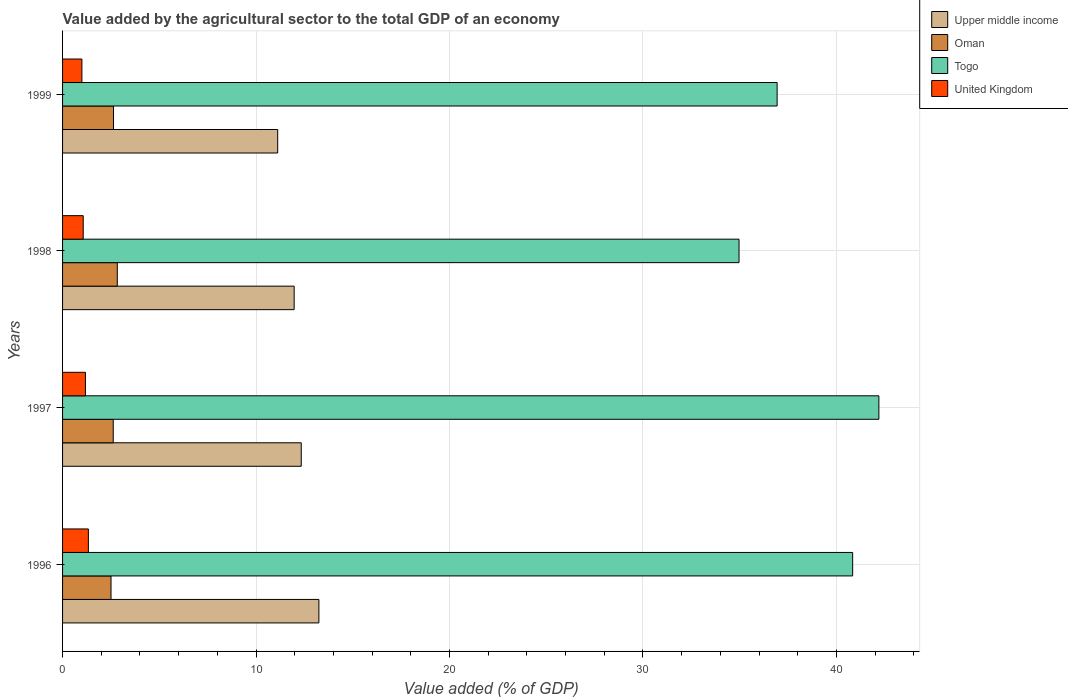How many different coloured bars are there?
Offer a very short reply. 4. Are the number of bars on each tick of the Y-axis equal?
Your answer should be very brief. Yes. How many bars are there on the 3rd tick from the bottom?
Make the answer very short. 4. What is the value added by the agricultural sector to the total GDP in Togo in 1999?
Keep it short and to the point. 36.93. Across all years, what is the maximum value added by the agricultural sector to the total GDP in Upper middle income?
Your response must be concise. 13.25. Across all years, what is the minimum value added by the agricultural sector to the total GDP in Togo?
Give a very brief answer. 34.96. In which year was the value added by the agricultural sector to the total GDP in United Kingdom maximum?
Make the answer very short. 1996. In which year was the value added by the agricultural sector to the total GDP in Oman minimum?
Ensure brevity in your answer.  1996. What is the total value added by the agricultural sector to the total GDP in Togo in the graph?
Ensure brevity in your answer.  154.93. What is the difference between the value added by the agricultural sector to the total GDP in Togo in 1997 and that in 1999?
Make the answer very short. 5.26. What is the difference between the value added by the agricultural sector to the total GDP in United Kingdom in 1998 and the value added by the agricultural sector to the total GDP in Togo in 1997?
Your answer should be compact. -41.13. What is the average value added by the agricultural sector to the total GDP in Oman per year?
Your response must be concise. 2.65. In the year 1996, what is the difference between the value added by the agricultural sector to the total GDP in United Kingdom and value added by the agricultural sector to the total GDP in Oman?
Your response must be concise. -1.17. In how many years, is the value added by the agricultural sector to the total GDP in Oman greater than 32 %?
Make the answer very short. 0. What is the ratio of the value added by the agricultural sector to the total GDP in United Kingdom in 1996 to that in 1998?
Your response must be concise. 1.25. Is the value added by the agricultural sector to the total GDP in United Kingdom in 1997 less than that in 1998?
Offer a terse response. No. What is the difference between the highest and the second highest value added by the agricultural sector to the total GDP in Togo?
Make the answer very short. 1.36. What is the difference between the highest and the lowest value added by the agricultural sector to the total GDP in Togo?
Provide a short and direct response. 7.23. In how many years, is the value added by the agricultural sector to the total GDP in Upper middle income greater than the average value added by the agricultural sector to the total GDP in Upper middle income taken over all years?
Your answer should be compact. 2. What does the 1st bar from the bottom in 1999 represents?
Keep it short and to the point. Upper middle income. How many years are there in the graph?
Keep it short and to the point. 4. Are the values on the major ticks of X-axis written in scientific E-notation?
Ensure brevity in your answer.  No. Does the graph contain any zero values?
Your response must be concise. No. Does the graph contain grids?
Provide a succinct answer. Yes. How are the legend labels stacked?
Ensure brevity in your answer.  Vertical. What is the title of the graph?
Offer a very short reply. Value added by the agricultural sector to the total GDP of an economy. What is the label or title of the X-axis?
Provide a succinct answer. Value added (% of GDP). What is the label or title of the Y-axis?
Your answer should be compact. Years. What is the Value added (% of GDP) in Upper middle income in 1996?
Offer a very short reply. 13.25. What is the Value added (% of GDP) of Oman in 1996?
Give a very brief answer. 2.5. What is the Value added (% of GDP) in Togo in 1996?
Ensure brevity in your answer.  40.84. What is the Value added (% of GDP) of United Kingdom in 1996?
Ensure brevity in your answer.  1.33. What is the Value added (% of GDP) of Upper middle income in 1997?
Offer a terse response. 12.34. What is the Value added (% of GDP) of Oman in 1997?
Offer a very short reply. 2.62. What is the Value added (% of GDP) of Togo in 1997?
Your answer should be compact. 42.19. What is the Value added (% of GDP) of United Kingdom in 1997?
Your response must be concise. 1.18. What is the Value added (% of GDP) in Upper middle income in 1998?
Ensure brevity in your answer.  11.97. What is the Value added (% of GDP) in Oman in 1998?
Offer a terse response. 2.83. What is the Value added (% of GDP) of Togo in 1998?
Your answer should be compact. 34.96. What is the Value added (% of GDP) of United Kingdom in 1998?
Your answer should be very brief. 1.07. What is the Value added (% of GDP) in Upper middle income in 1999?
Give a very brief answer. 11.12. What is the Value added (% of GDP) of Oman in 1999?
Make the answer very short. 2.63. What is the Value added (% of GDP) of Togo in 1999?
Your answer should be compact. 36.93. What is the Value added (% of GDP) in United Kingdom in 1999?
Offer a very short reply. 1. Across all years, what is the maximum Value added (% of GDP) in Upper middle income?
Your answer should be very brief. 13.25. Across all years, what is the maximum Value added (% of GDP) of Oman?
Keep it short and to the point. 2.83. Across all years, what is the maximum Value added (% of GDP) of Togo?
Offer a terse response. 42.19. Across all years, what is the maximum Value added (% of GDP) in United Kingdom?
Keep it short and to the point. 1.33. Across all years, what is the minimum Value added (% of GDP) of Upper middle income?
Give a very brief answer. 11.12. Across all years, what is the minimum Value added (% of GDP) of Oman?
Keep it short and to the point. 2.5. Across all years, what is the minimum Value added (% of GDP) of Togo?
Offer a terse response. 34.96. Across all years, what is the minimum Value added (% of GDP) in United Kingdom?
Make the answer very short. 1. What is the total Value added (% of GDP) of Upper middle income in the graph?
Provide a short and direct response. 48.67. What is the total Value added (% of GDP) of Oman in the graph?
Provide a succinct answer. 10.58. What is the total Value added (% of GDP) in Togo in the graph?
Your answer should be compact. 154.93. What is the total Value added (% of GDP) of United Kingdom in the graph?
Give a very brief answer. 4.58. What is the difference between the Value added (% of GDP) of Upper middle income in 1996 and that in 1997?
Keep it short and to the point. 0.91. What is the difference between the Value added (% of GDP) in Oman in 1996 and that in 1997?
Keep it short and to the point. -0.12. What is the difference between the Value added (% of GDP) in Togo in 1996 and that in 1997?
Give a very brief answer. -1.36. What is the difference between the Value added (% of GDP) in United Kingdom in 1996 and that in 1997?
Give a very brief answer. 0.15. What is the difference between the Value added (% of GDP) in Upper middle income in 1996 and that in 1998?
Ensure brevity in your answer.  1.28. What is the difference between the Value added (% of GDP) of Oman in 1996 and that in 1998?
Give a very brief answer. -0.32. What is the difference between the Value added (% of GDP) in Togo in 1996 and that in 1998?
Offer a terse response. 5.87. What is the difference between the Value added (% of GDP) of United Kingdom in 1996 and that in 1998?
Make the answer very short. 0.27. What is the difference between the Value added (% of GDP) of Upper middle income in 1996 and that in 1999?
Offer a very short reply. 2.13. What is the difference between the Value added (% of GDP) in Oman in 1996 and that in 1999?
Give a very brief answer. -0.13. What is the difference between the Value added (% of GDP) in Togo in 1996 and that in 1999?
Ensure brevity in your answer.  3.9. What is the difference between the Value added (% of GDP) in United Kingdom in 1996 and that in 1999?
Your answer should be very brief. 0.33. What is the difference between the Value added (% of GDP) of Upper middle income in 1997 and that in 1998?
Provide a succinct answer. 0.37. What is the difference between the Value added (% of GDP) of Oman in 1997 and that in 1998?
Keep it short and to the point. -0.21. What is the difference between the Value added (% of GDP) in Togo in 1997 and that in 1998?
Ensure brevity in your answer.  7.23. What is the difference between the Value added (% of GDP) of United Kingdom in 1997 and that in 1998?
Your response must be concise. 0.12. What is the difference between the Value added (% of GDP) of Upper middle income in 1997 and that in 1999?
Your answer should be very brief. 1.22. What is the difference between the Value added (% of GDP) of Oman in 1997 and that in 1999?
Offer a very short reply. -0.01. What is the difference between the Value added (% of GDP) in Togo in 1997 and that in 1999?
Your answer should be very brief. 5.26. What is the difference between the Value added (% of GDP) in United Kingdom in 1997 and that in 1999?
Make the answer very short. 0.18. What is the difference between the Value added (% of GDP) of Upper middle income in 1998 and that in 1999?
Give a very brief answer. 0.85. What is the difference between the Value added (% of GDP) of Oman in 1998 and that in 1999?
Provide a succinct answer. 0.2. What is the difference between the Value added (% of GDP) in Togo in 1998 and that in 1999?
Offer a terse response. -1.97. What is the difference between the Value added (% of GDP) in United Kingdom in 1998 and that in 1999?
Provide a short and direct response. 0.07. What is the difference between the Value added (% of GDP) in Upper middle income in 1996 and the Value added (% of GDP) in Oman in 1997?
Make the answer very short. 10.63. What is the difference between the Value added (% of GDP) in Upper middle income in 1996 and the Value added (% of GDP) in Togo in 1997?
Provide a short and direct response. -28.94. What is the difference between the Value added (% of GDP) of Upper middle income in 1996 and the Value added (% of GDP) of United Kingdom in 1997?
Offer a very short reply. 12.07. What is the difference between the Value added (% of GDP) of Oman in 1996 and the Value added (% of GDP) of Togo in 1997?
Make the answer very short. -39.69. What is the difference between the Value added (% of GDP) in Oman in 1996 and the Value added (% of GDP) in United Kingdom in 1997?
Your answer should be compact. 1.32. What is the difference between the Value added (% of GDP) in Togo in 1996 and the Value added (% of GDP) in United Kingdom in 1997?
Your response must be concise. 39.65. What is the difference between the Value added (% of GDP) in Upper middle income in 1996 and the Value added (% of GDP) in Oman in 1998?
Your answer should be compact. 10.42. What is the difference between the Value added (% of GDP) of Upper middle income in 1996 and the Value added (% of GDP) of Togo in 1998?
Provide a succinct answer. -21.72. What is the difference between the Value added (% of GDP) of Upper middle income in 1996 and the Value added (% of GDP) of United Kingdom in 1998?
Your answer should be compact. 12.18. What is the difference between the Value added (% of GDP) in Oman in 1996 and the Value added (% of GDP) in Togo in 1998?
Provide a short and direct response. -32.46. What is the difference between the Value added (% of GDP) in Oman in 1996 and the Value added (% of GDP) in United Kingdom in 1998?
Keep it short and to the point. 1.44. What is the difference between the Value added (% of GDP) of Togo in 1996 and the Value added (% of GDP) of United Kingdom in 1998?
Your answer should be compact. 39.77. What is the difference between the Value added (% of GDP) of Upper middle income in 1996 and the Value added (% of GDP) of Oman in 1999?
Ensure brevity in your answer.  10.62. What is the difference between the Value added (% of GDP) of Upper middle income in 1996 and the Value added (% of GDP) of Togo in 1999?
Provide a succinct answer. -23.68. What is the difference between the Value added (% of GDP) of Upper middle income in 1996 and the Value added (% of GDP) of United Kingdom in 1999?
Give a very brief answer. 12.25. What is the difference between the Value added (% of GDP) in Oman in 1996 and the Value added (% of GDP) in Togo in 1999?
Ensure brevity in your answer.  -34.43. What is the difference between the Value added (% of GDP) of Oman in 1996 and the Value added (% of GDP) of United Kingdom in 1999?
Make the answer very short. 1.5. What is the difference between the Value added (% of GDP) of Togo in 1996 and the Value added (% of GDP) of United Kingdom in 1999?
Your answer should be compact. 39.84. What is the difference between the Value added (% of GDP) of Upper middle income in 1997 and the Value added (% of GDP) of Oman in 1998?
Your answer should be compact. 9.51. What is the difference between the Value added (% of GDP) in Upper middle income in 1997 and the Value added (% of GDP) in Togo in 1998?
Make the answer very short. -22.63. What is the difference between the Value added (% of GDP) in Upper middle income in 1997 and the Value added (% of GDP) in United Kingdom in 1998?
Provide a short and direct response. 11.27. What is the difference between the Value added (% of GDP) of Oman in 1997 and the Value added (% of GDP) of Togo in 1998?
Keep it short and to the point. -32.34. What is the difference between the Value added (% of GDP) of Oman in 1997 and the Value added (% of GDP) of United Kingdom in 1998?
Make the answer very short. 1.55. What is the difference between the Value added (% of GDP) in Togo in 1997 and the Value added (% of GDP) in United Kingdom in 1998?
Your answer should be very brief. 41.13. What is the difference between the Value added (% of GDP) in Upper middle income in 1997 and the Value added (% of GDP) in Oman in 1999?
Provide a succinct answer. 9.7. What is the difference between the Value added (% of GDP) in Upper middle income in 1997 and the Value added (% of GDP) in Togo in 1999?
Provide a short and direct response. -24.6. What is the difference between the Value added (% of GDP) in Upper middle income in 1997 and the Value added (% of GDP) in United Kingdom in 1999?
Make the answer very short. 11.34. What is the difference between the Value added (% of GDP) of Oman in 1997 and the Value added (% of GDP) of Togo in 1999?
Provide a short and direct response. -34.31. What is the difference between the Value added (% of GDP) in Oman in 1997 and the Value added (% of GDP) in United Kingdom in 1999?
Offer a terse response. 1.62. What is the difference between the Value added (% of GDP) in Togo in 1997 and the Value added (% of GDP) in United Kingdom in 1999?
Your answer should be compact. 41.19. What is the difference between the Value added (% of GDP) of Upper middle income in 1998 and the Value added (% of GDP) of Oman in 1999?
Ensure brevity in your answer.  9.34. What is the difference between the Value added (% of GDP) in Upper middle income in 1998 and the Value added (% of GDP) in Togo in 1999?
Give a very brief answer. -24.96. What is the difference between the Value added (% of GDP) in Upper middle income in 1998 and the Value added (% of GDP) in United Kingdom in 1999?
Your answer should be compact. 10.97. What is the difference between the Value added (% of GDP) in Oman in 1998 and the Value added (% of GDP) in Togo in 1999?
Your response must be concise. -34.1. What is the difference between the Value added (% of GDP) of Oman in 1998 and the Value added (% of GDP) of United Kingdom in 1999?
Your answer should be very brief. 1.83. What is the difference between the Value added (% of GDP) in Togo in 1998 and the Value added (% of GDP) in United Kingdom in 1999?
Make the answer very short. 33.96. What is the average Value added (% of GDP) of Upper middle income per year?
Offer a terse response. 12.17. What is the average Value added (% of GDP) in Oman per year?
Your response must be concise. 2.65. What is the average Value added (% of GDP) of Togo per year?
Offer a very short reply. 38.73. What is the average Value added (% of GDP) in United Kingdom per year?
Offer a very short reply. 1.15. In the year 1996, what is the difference between the Value added (% of GDP) in Upper middle income and Value added (% of GDP) in Oman?
Make the answer very short. 10.74. In the year 1996, what is the difference between the Value added (% of GDP) in Upper middle income and Value added (% of GDP) in Togo?
Keep it short and to the point. -27.59. In the year 1996, what is the difference between the Value added (% of GDP) of Upper middle income and Value added (% of GDP) of United Kingdom?
Keep it short and to the point. 11.91. In the year 1996, what is the difference between the Value added (% of GDP) in Oman and Value added (% of GDP) in Togo?
Your answer should be very brief. -38.33. In the year 1996, what is the difference between the Value added (% of GDP) in Oman and Value added (% of GDP) in United Kingdom?
Your response must be concise. 1.17. In the year 1996, what is the difference between the Value added (% of GDP) in Togo and Value added (% of GDP) in United Kingdom?
Provide a succinct answer. 39.5. In the year 1997, what is the difference between the Value added (% of GDP) of Upper middle income and Value added (% of GDP) of Oman?
Give a very brief answer. 9.72. In the year 1997, what is the difference between the Value added (% of GDP) in Upper middle income and Value added (% of GDP) in Togo?
Your response must be concise. -29.86. In the year 1997, what is the difference between the Value added (% of GDP) in Upper middle income and Value added (% of GDP) in United Kingdom?
Your response must be concise. 11.15. In the year 1997, what is the difference between the Value added (% of GDP) of Oman and Value added (% of GDP) of Togo?
Offer a terse response. -39.57. In the year 1997, what is the difference between the Value added (% of GDP) in Oman and Value added (% of GDP) in United Kingdom?
Make the answer very short. 1.44. In the year 1997, what is the difference between the Value added (% of GDP) in Togo and Value added (% of GDP) in United Kingdom?
Make the answer very short. 41.01. In the year 1998, what is the difference between the Value added (% of GDP) in Upper middle income and Value added (% of GDP) in Oman?
Give a very brief answer. 9.14. In the year 1998, what is the difference between the Value added (% of GDP) in Upper middle income and Value added (% of GDP) in Togo?
Provide a short and direct response. -22.99. In the year 1998, what is the difference between the Value added (% of GDP) of Upper middle income and Value added (% of GDP) of United Kingdom?
Provide a short and direct response. 10.9. In the year 1998, what is the difference between the Value added (% of GDP) in Oman and Value added (% of GDP) in Togo?
Provide a succinct answer. -32.13. In the year 1998, what is the difference between the Value added (% of GDP) in Oman and Value added (% of GDP) in United Kingdom?
Offer a very short reply. 1.76. In the year 1998, what is the difference between the Value added (% of GDP) of Togo and Value added (% of GDP) of United Kingdom?
Your answer should be compact. 33.9. In the year 1999, what is the difference between the Value added (% of GDP) of Upper middle income and Value added (% of GDP) of Oman?
Your answer should be compact. 8.49. In the year 1999, what is the difference between the Value added (% of GDP) of Upper middle income and Value added (% of GDP) of Togo?
Your answer should be compact. -25.81. In the year 1999, what is the difference between the Value added (% of GDP) of Upper middle income and Value added (% of GDP) of United Kingdom?
Provide a short and direct response. 10.12. In the year 1999, what is the difference between the Value added (% of GDP) of Oman and Value added (% of GDP) of Togo?
Your answer should be very brief. -34.3. In the year 1999, what is the difference between the Value added (% of GDP) of Oman and Value added (% of GDP) of United Kingdom?
Give a very brief answer. 1.63. In the year 1999, what is the difference between the Value added (% of GDP) in Togo and Value added (% of GDP) in United Kingdom?
Ensure brevity in your answer.  35.93. What is the ratio of the Value added (% of GDP) of Upper middle income in 1996 to that in 1997?
Provide a short and direct response. 1.07. What is the ratio of the Value added (% of GDP) of Oman in 1996 to that in 1997?
Provide a short and direct response. 0.96. What is the ratio of the Value added (% of GDP) in Togo in 1996 to that in 1997?
Provide a short and direct response. 0.97. What is the ratio of the Value added (% of GDP) of United Kingdom in 1996 to that in 1997?
Give a very brief answer. 1.13. What is the ratio of the Value added (% of GDP) in Upper middle income in 1996 to that in 1998?
Keep it short and to the point. 1.11. What is the ratio of the Value added (% of GDP) of Oman in 1996 to that in 1998?
Make the answer very short. 0.89. What is the ratio of the Value added (% of GDP) in Togo in 1996 to that in 1998?
Your answer should be compact. 1.17. What is the ratio of the Value added (% of GDP) of United Kingdom in 1996 to that in 1998?
Ensure brevity in your answer.  1.25. What is the ratio of the Value added (% of GDP) in Upper middle income in 1996 to that in 1999?
Keep it short and to the point. 1.19. What is the ratio of the Value added (% of GDP) of Oman in 1996 to that in 1999?
Provide a short and direct response. 0.95. What is the ratio of the Value added (% of GDP) of Togo in 1996 to that in 1999?
Offer a terse response. 1.11. What is the ratio of the Value added (% of GDP) of United Kingdom in 1996 to that in 1999?
Make the answer very short. 1.33. What is the ratio of the Value added (% of GDP) in Upper middle income in 1997 to that in 1998?
Make the answer very short. 1.03. What is the ratio of the Value added (% of GDP) of Oman in 1997 to that in 1998?
Offer a very short reply. 0.93. What is the ratio of the Value added (% of GDP) in Togo in 1997 to that in 1998?
Make the answer very short. 1.21. What is the ratio of the Value added (% of GDP) in United Kingdom in 1997 to that in 1998?
Your response must be concise. 1.11. What is the ratio of the Value added (% of GDP) of Upper middle income in 1997 to that in 1999?
Your answer should be very brief. 1.11. What is the ratio of the Value added (% of GDP) in Oman in 1997 to that in 1999?
Make the answer very short. 1. What is the ratio of the Value added (% of GDP) in Togo in 1997 to that in 1999?
Your answer should be compact. 1.14. What is the ratio of the Value added (% of GDP) of United Kingdom in 1997 to that in 1999?
Ensure brevity in your answer.  1.18. What is the ratio of the Value added (% of GDP) of Upper middle income in 1998 to that in 1999?
Make the answer very short. 1.08. What is the ratio of the Value added (% of GDP) in Oman in 1998 to that in 1999?
Ensure brevity in your answer.  1.07. What is the ratio of the Value added (% of GDP) in Togo in 1998 to that in 1999?
Your answer should be compact. 0.95. What is the ratio of the Value added (% of GDP) of United Kingdom in 1998 to that in 1999?
Make the answer very short. 1.07. What is the difference between the highest and the second highest Value added (% of GDP) of Upper middle income?
Offer a very short reply. 0.91. What is the difference between the highest and the second highest Value added (% of GDP) in Oman?
Make the answer very short. 0.2. What is the difference between the highest and the second highest Value added (% of GDP) of Togo?
Offer a very short reply. 1.36. What is the difference between the highest and the second highest Value added (% of GDP) in United Kingdom?
Provide a succinct answer. 0.15. What is the difference between the highest and the lowest Value added (% of GDP) in Upper middle income?
Ensure brevity in your answer.  2.13. What is the difference between the highest and the lowest Value added (% of GDP) of Oman?
Keep it short and to the point. 0.32. What is the difference between the highest and the lowest Value added (% of GDP) of Togo?
Offer a very short reply. 7.23. What is the difference between the highest and the lowest Value added (% of GDP) of United Kingdom?
Ensure brevity in your answer.  0.33. 